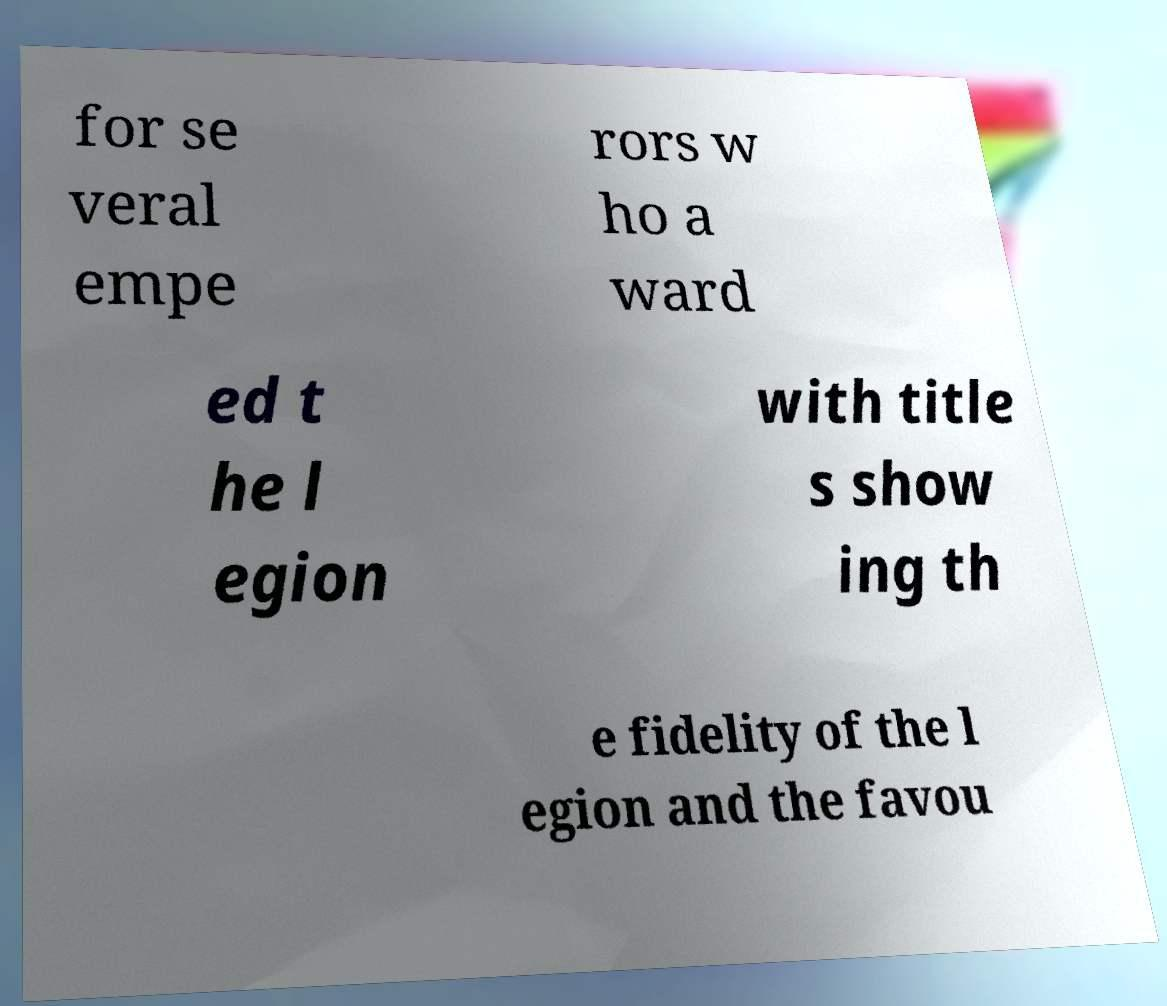There's text embedded in this image that I need extracted. Can you transcribe it verbatim? for se veral empe rors w ho a ward ed t he l egion with title s show ing th e fidelity of the l egion and the favou 